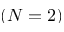<formula> <loc_0><loc_0><loc_500><loc_500>( N = 2 )</formula> 